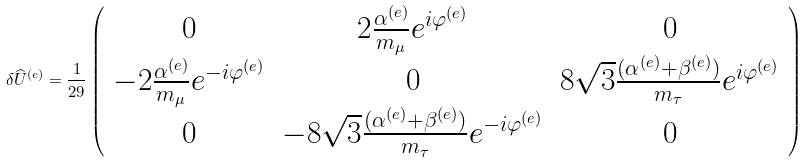<formula> <loc_0><loc_0><loc_500><loc_500>\delta \widehat { U } ^ { ( e ) } = \frac { 1 } { 2 9 } \left ( \begin{array} { c c c } 0 & 2 \frac { \alpha ^ { ( e ) } } { m _ { \mu } } e ^ { i \varphi ^ { ( e ) } } & 0 \\ - 2 \frac { \alpha ^ { ( e ) } } { m _ { \mu } } e ^ { - i \varphi ^ { ( e ) } } & 0 & 8 \sqrt { 3 } \frac { ( \alpha ^ { ( e ) } + \beta ^ { ( e ) } ) } { m _ { \tau } } e ^ { i \varphi ^ { ( e ) } } \\ 0 & - 8 \sqrt { 3 } \frac { ( \alpha ^ { ( e ) } + \beta ^ { ( e ) } ) } { m _ { \tau } } e ^ { - i \varphi ^ { ( e ) } } & 0 \end{array} \right )</formula> 